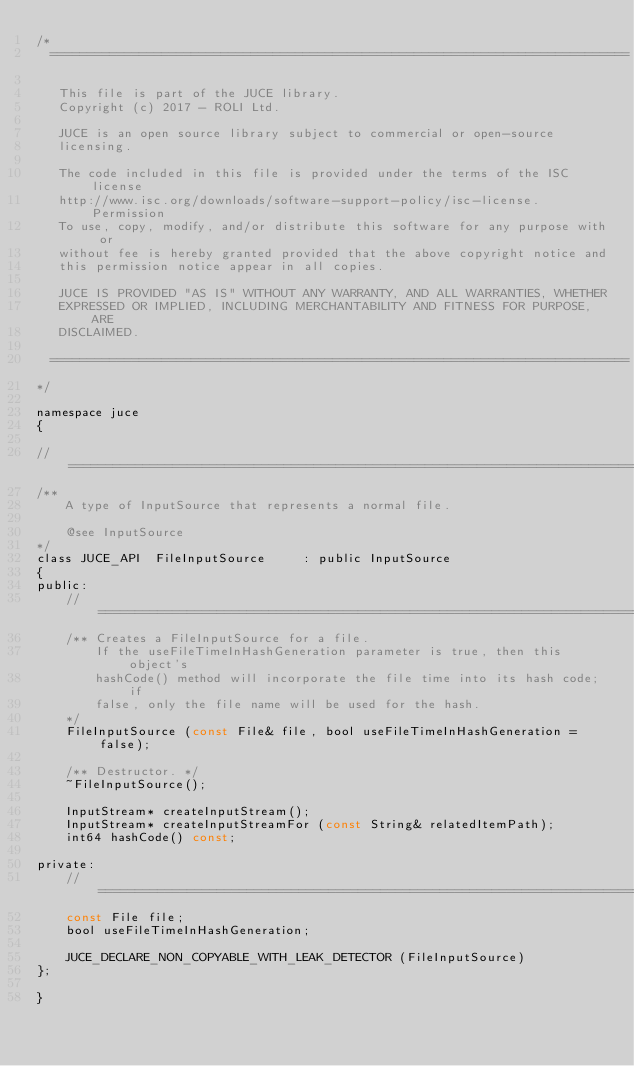Convert code to text. <code><loc_0><loc_0><loc_500><loc_500><_C_>/*
  ==============================================================================

   This file is part of the JUCE library.
   Copyright (c) 2017 - ROLI Ltd.

   JUCE is an open source library subject to commercial or open-source
   licensing.

   The code included in this file is provided under the terms of the ISC license
   http://www.isc.org/downloads/software-support-policy/isc-license. Permission
   To use, copy, modify, and/or distribute this software for any purpose with or
   without fee is hereby granted provided that the above copyright notice and
   this permission notice appear in all copies.

   JUCE IS PROVIDED "AS IS" WITHOUT ANY WARRANTY, AND ALL WARRANTIES, WHETHER
   EXPRESSED OR IMPLIED, INCLUDING MERCHANTABILITY AND FITNESS FOR PURPOSE, ARE
   DISCLAIMED.

  ==============================================================================
*/

namespace juce
{

//==============================================================================
/**
    A type of InputSource that represents a normal file.

    @see InputSource
*/
class JUCE_API  FileInputSource     : public InputSource
{
public:
    //==============================================================================
    /** Creates a FileInputSource for a file.
        If the useFileTimeInHashGeneration parameter is true, then this object's
        hashCode() method will incorporate the file time into its hash code; if
        false, only the file name will be used for the hash.
    */
    FileInputSource (const File& file, bool useFileTimeInHashGeneration = false);

    /** Destructor. */
    ~FileInputSource();

    InputStream* createInputStream();
    InputStream* createInputStreamFor (const String& relatedItemPath);
    int64 hashCode() const;

private:
    //==============================================================================
    const File file;
    bool useFileTimeInHashGeneration;

    JUCE_DECLARE_NON_COPYABLE_WITH_LEAK_DETECTOR (FileInputSource)
};

}
</code> 